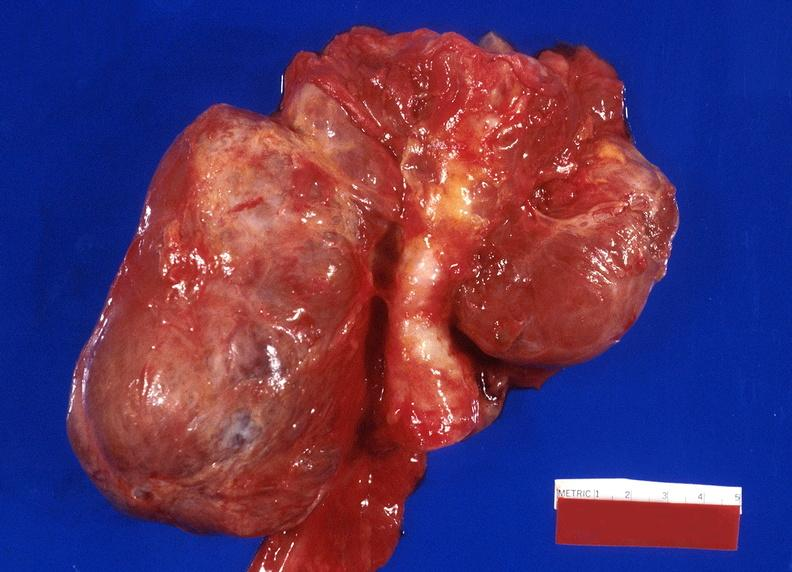does subdiaphragmatic abscess show thyroid, goiter?
Answer the question using a single word or phrase. No 